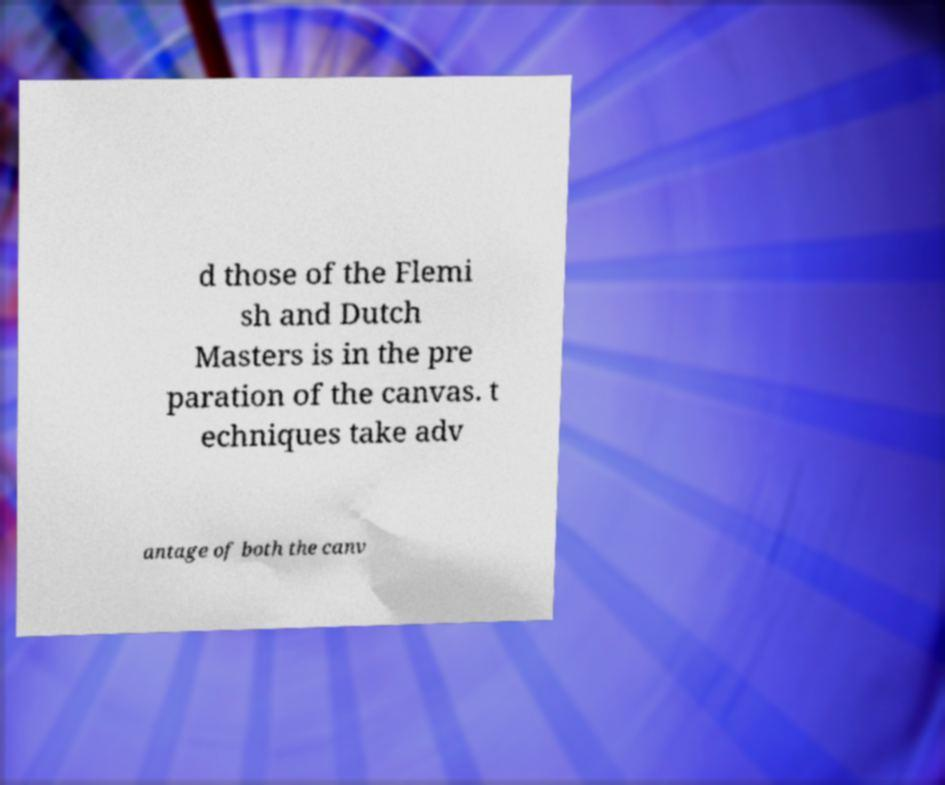I need the written content from this picture converted into text. Can you do that? d those of the Flemi sh and Dutch Masters is in the pre paration of the canvas. t echniques take adv antage of both the canv 